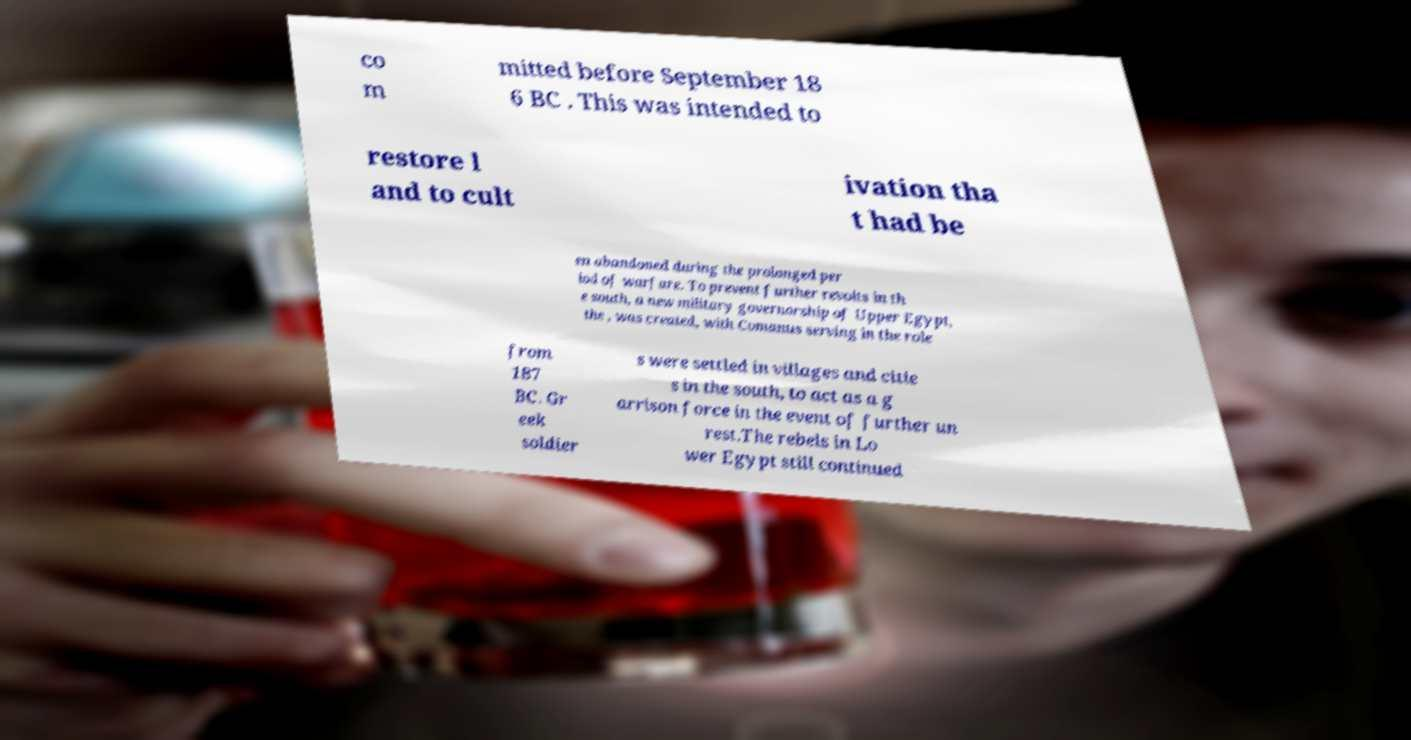Could you extract and type out the text from this image? co m mitted before September 18 6 BC . This was intended to restore l and to cult ivation tha t had be en abandoned during the prolonged per iod of warfare. To prevent further revolts in th e south, a new military governorship of Upper Egypt, the , was created, with Comanus serving in the role from 187 BC. Gr eek soldier s were settled in villages and citie s in the south, to act as a g arrison force in the event of further un rest.The rebels in Lo wer Egypt still continued 